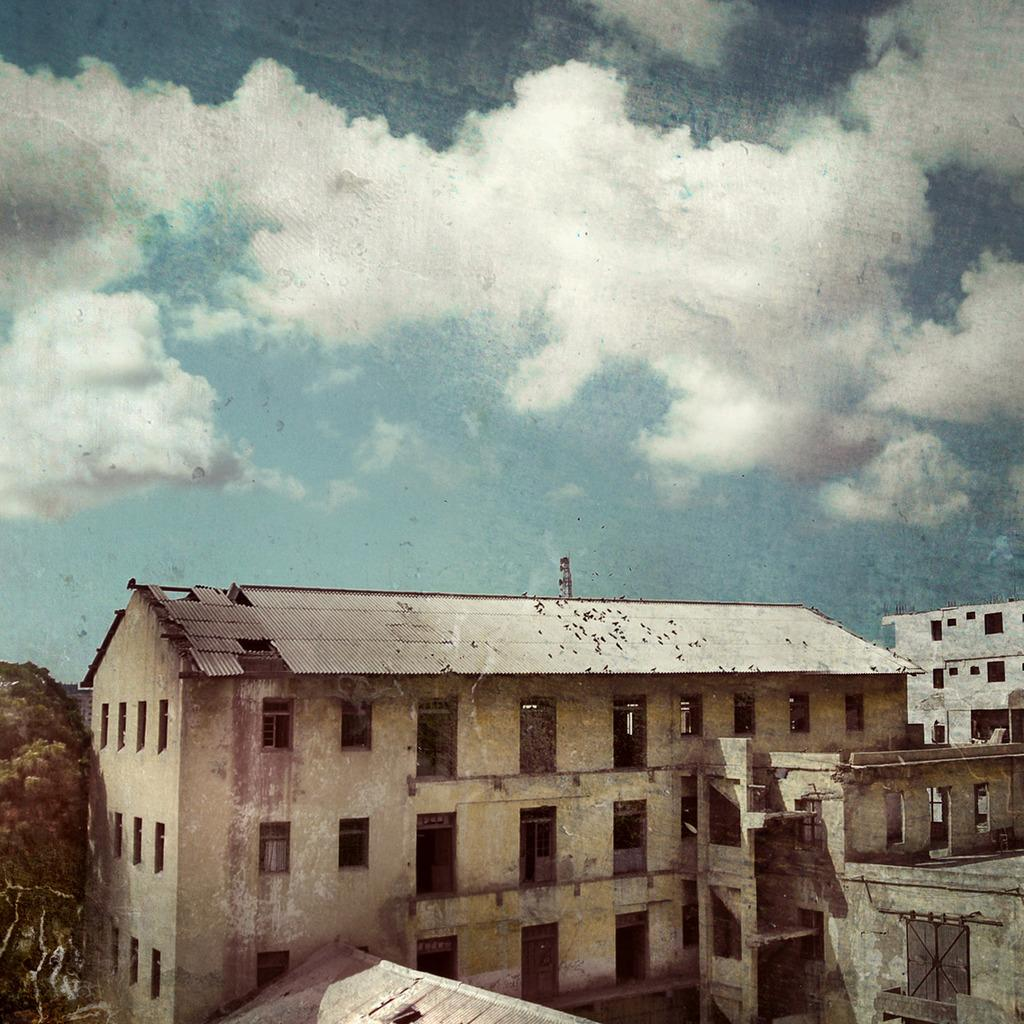What type of structures are located at the bottom of the image? There are buildings at the bottom of the image. What can be seen on the left side of the image? There is a tree on the left side of the image. What is visible at the top of the image? The sky is visible at the top of the image. Can you tell me how many trains are passing by the queen in the image? There is no queen or railway present in the image, so it is not possible to answer that question. 